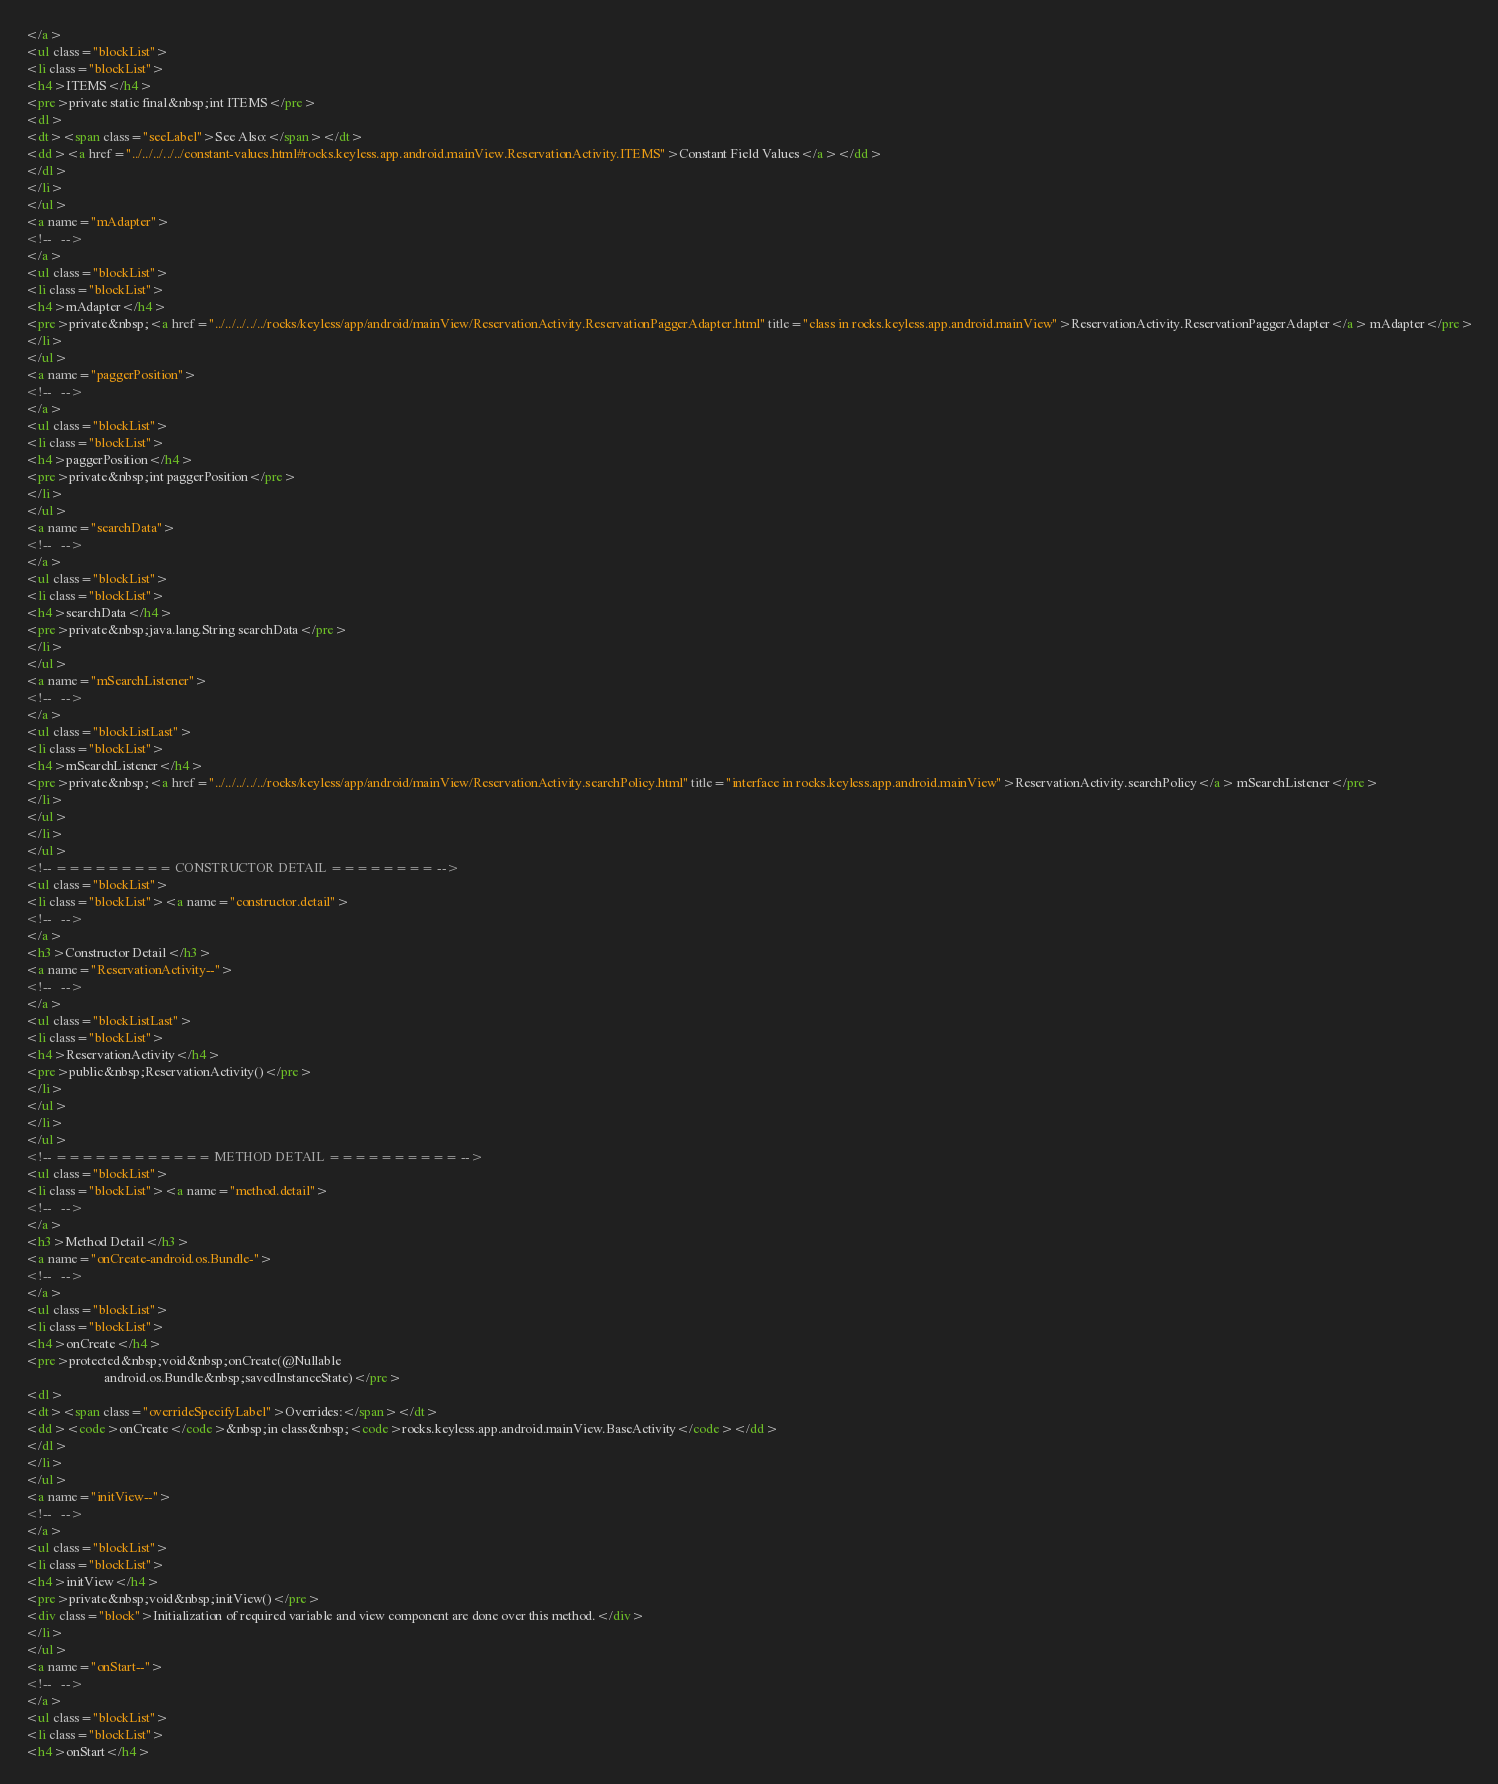<code> <loc_0><loc_0><loc_500><loc_500><_HTML_></a>
<ul class="blockList">
<li class="blockList">
<h4>ITEMS</h4>
<pre>private static final&nbsp;int ITEMS</pre>
<dl>
<dt><span class="seeLabel">See Also:</span></dt>
<dd><a href="../../../../../constant-values.html#rocks.keyless.app.android.mainView.ReservationActivity.ITEMS">Constant Field Values</a></dd>
</dl>
</li>
</ul>
<a name="mAdapter">
<!--   -->
</a>
<ul class="blockList">
<li class="blockList">
<h4>mAdapter</h4>
<pre>private&nbsp;<a href="../../../../../rocks/keyless/app/android/mainView/ReservationActivity.ReservationPaggerAdapter.html" title="class in rocks.keyless.app.android.mainView">ReservationActivity.ReservationPaggerAdapter</a> mAdapter</pre>
</li>
</ul>
<a name="paggerPosition">
<!--   -->
</a>
<ul class="blockList">
<li class="blockList">
<h4>paggerPosition</h4>
<pre>private&nbsp;int paggerPosition</pre>
</li>
</ul>
<a name="searchData">
<!--   -->
</a>
<ul class="blockList">
<li class="blockList">
<h4>searchData</h4>
<pre>private&nbsp;java.lang.String searchData</pre>
</li>
</ul>
<a name="mSearchListener">
<!--   -->
</a>
<ul class="blockListLast">
<li class="blockList">
<h4>mSearchListener</h4>
<pre>private&nbsp;<a href="../../../../../rocks/keyless/app/android/mainView/ReservationActivity.searchPolicy.html" title="interface in rocks.keyless.app.android.mainView">ReservationActivity.searchPolicy</a> mSearchListener</pre>
</li>
</ul>
</li>
</ul>
<!-- ========= CONSTRUCTOR DETAIL ======== -->
<ul class="blockList">
<li class="blockList"><a name="constructor.detail">
<!--   -->
</a>
<h3>Constructor Detail</h3>
<a name="ReservationActivity--">
<!--   -->
</a>
<ul class="blockListLast">
<li class="blockList">
<h4>ReservationActivity</h4>
<pre>public&nbsp;ReservationActivity()</pre>
</li>
</ul>
</li>
</ul>
<!-- ============ METHOD DETAIL ========== -->
<ul class="blockList">
<li class="blockList"><a name="method.detail">
<!--   -->
</a>
<h3>Method Detail</h3>
<a name="onCreate-android.os.Bundle-">
<!--   -->
</a>
<ul class="blockList">
<li class="blockList">
<h4>onCreate</h4>
<pre>protected&nbsp;void&nbsp;onCreate(@Nullable
                        android.os.Bundle&nbsp;savedInstanceState)</pre>
<dl>
<dt><span class="overrideSpecifyLabel">Overrides:</span></dt>
<dd><code>onCreate</code>&nbsp;in class&nbsp;<code>rocks.keyless.app.android.mainView.BaseActivity</code></dd>
</dl>
</li>
</ul>
<a name="initView--">
<!--   -->
</a>
<ul class="blockList">
<li class="blockList">
<h4>initView</h4>
<pre>private&nbsp;void&nbsp;initView()</pre>
<div class="block">Initialization of required variable and view component are done over this method.</div>
</li>
</ul>
<a name="onStart--">
<!--   -->
</a>
<ul class="blockList">
<li class="blockList">
<h4>onStart</h4></code> 